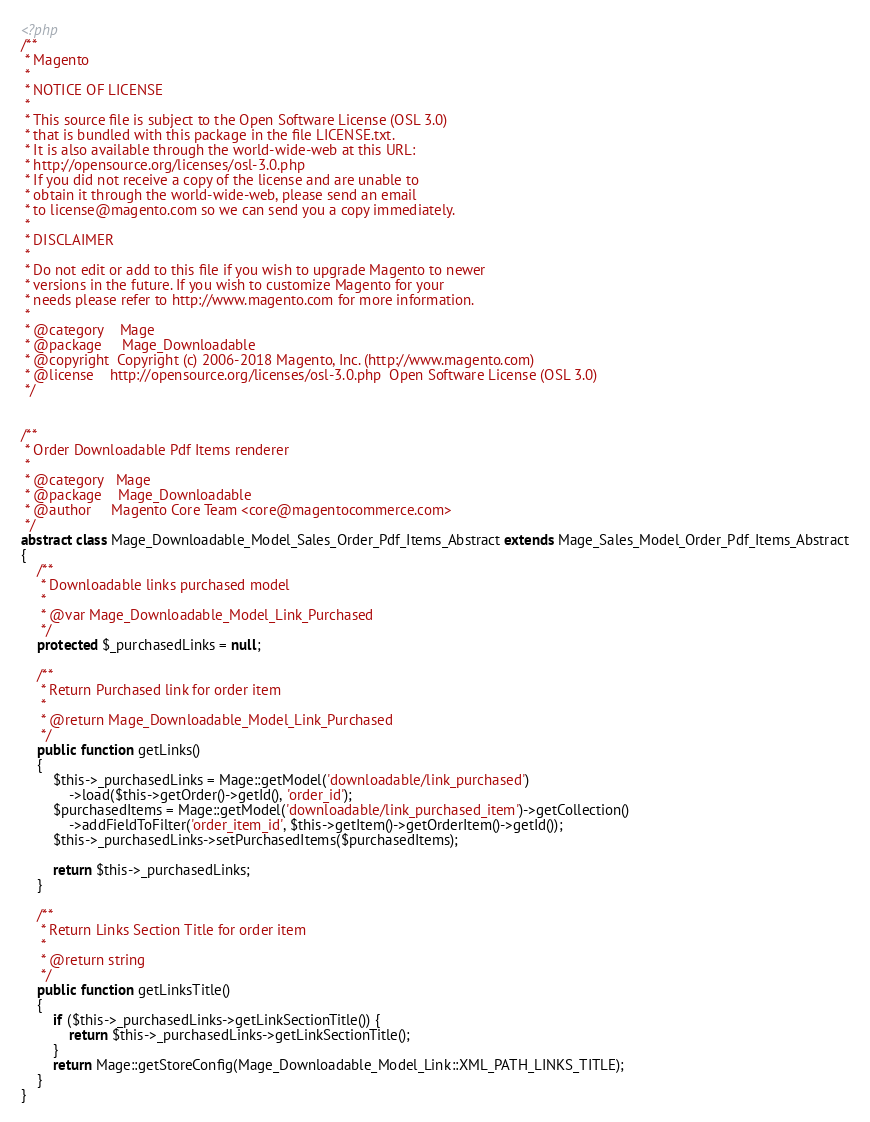<code> <loc_0><loc_0><loc_500><loc_500><_PHP_><?php
/**
 * Magento
 *
 * NOTICE OF LICENSE
 *
 * This source file is subject to the Open Software License (OSL 3.0)
 * that is bundled with this package in the file LICENSE.txt.
 * It is also available through the world-wide-web at this URL:
 * http://opensource.org/licenses/osl-3.0.php
 * If you did not receive a copy of the license and are unable to
 * obtain it through the world-wide-web, please send an email
 * to license@magento.com so we can send you a copy immediately.
 *
 * DISCLAIMER
 *
 * Do not edit or add to this file if you wish to upgrade Magento to newer
 * versions in the future. If you wish to customize Magento for your
 * needs please refer to http://www.magento.com for more information.
 *
 * @category    Mage
 * @package     Mage_Downloadable
 * @copyright  Copyright (c) 2006-2018 Magento, Inc. (http://www.magento.com)
 * @license    http://opensource.org/licenses/osl-3.0.php  Open Software License (OSL 3.0)
 */


/**
 * Order Downloadable Pdf Items renderer
 *
 * @category   Mage
 * @package    Mage_Downloadable
 * @author     Magento Core Team <core@magentocommerce.com>
 */
abstract class Mage_Downloadable_Model_Sales_Order_Pdf_Items_Abstract extends Mage_Sales_Model_Order_Pdf_Items_Abstract
{
    /**
     * Downloadable links purchased model
     *
     * @var Mage_Downloadable_Model_Link_Purchased
     */
    protected $_purchasedLinks = null;

    /**
     * Return Purchased link for order item
     *
     * @return Mage_Downloadable_Model_Link_Purchased
     */
    public function getLinks()
    {
        $this->_purchasedLinks = Mage::getModel('downloadable/link_purchased')
            ->load($this->getOrder()->getId(), 'order_id');
        $purchasedItems = Mage::getModel('downloadable/link_purchased_item')->getCollection()
            ->addFieldToFilter('order_item_id', $this->getItem()->getOrderItem()->getId());
        $this->_purchasedLinks->setPurchasedItems($purchasedItems);

        return $this->_purchasedLinks;
    }

    /**
     * Return Links Section Title for order item
     *
     * @return string
     */
    public function getLinksTitle()
    {
        if ($this->_purchasedLinks->getLinkSectionTitle()) {
            return $this->_purchasedLinks->getLinkSectionTitle();
        }
        return Mage::getStoreConfig(Mage_Downloadable_Model_Link::XML_PATH_LINKS_TITLE);
    }
}
</code> 